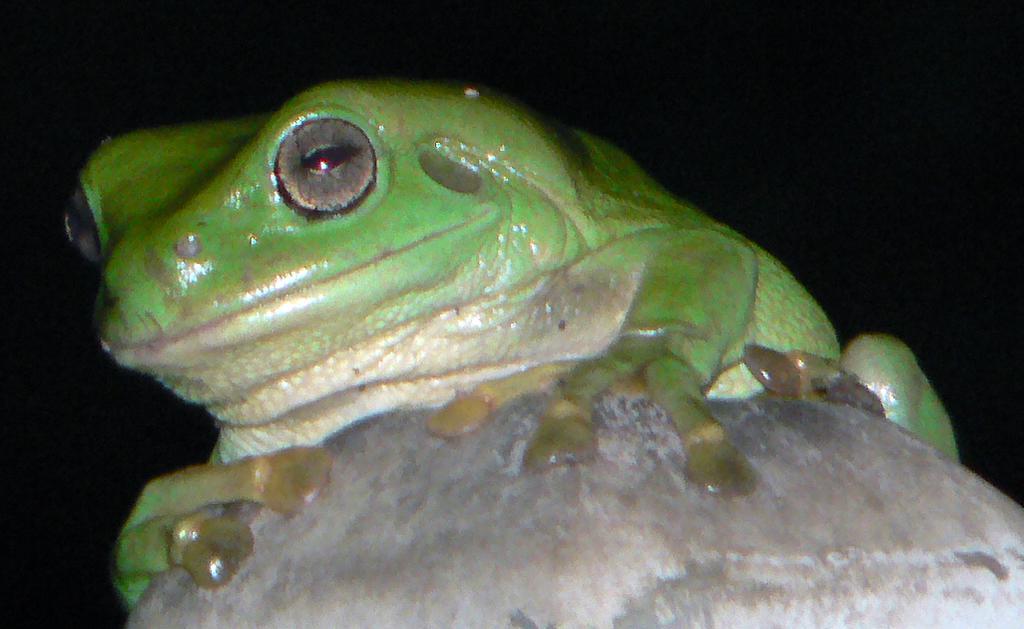Please provide a concise description of this image. In this image there is a green colour frog on the stone. 